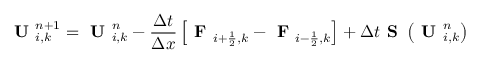<formula> <loc_0><loc_0><loc_500><loc_500>U _ { i , k } ^ { n + 1 } = U _ { i , k } ^ { n } - \frac { \Delta t } { \Delta x } \left [ F _ { i + \frac { 1 } { 2 } , k } - F _ { i - \frac { 1 } { 2 } , k } \right ] + \Delta t S \left ( U _ { i , k } ^ { n } \right )</formula> 